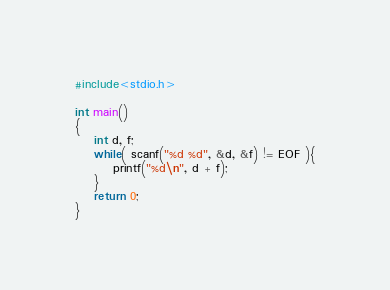<code> <loc_0><loc_0><loc_500><loc_500><_C_>
#include<stdio.h>

int main()
{
    int d, f;
    while( scanf("%d %d", &d, &f) != EOF ){
        printf("%d\n", d + f);
    }
    return 0;
}

</code> 